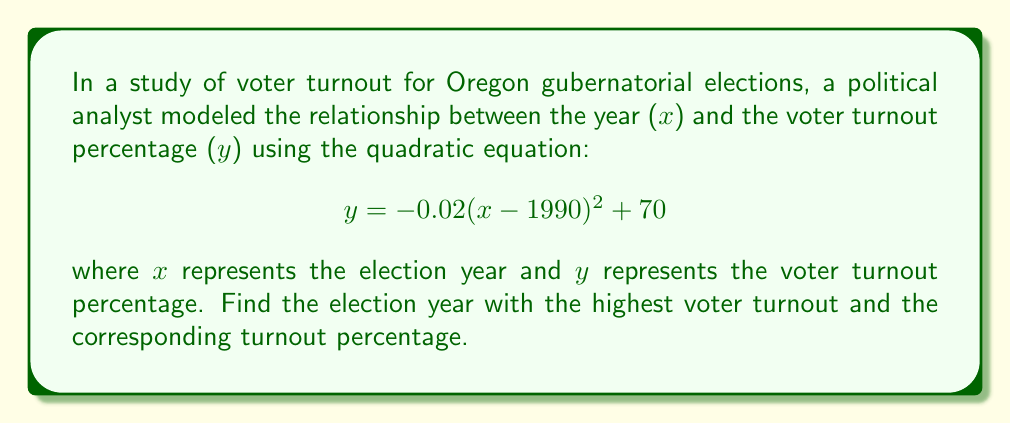Solve this math problem. To solve this problem, we need to find the vertex of the parabola, which represents the maximum point of the quadratic function. The general form of a quadratic equation is:

$$ y = a(x - h)^2 + k $$

where (h, k) is the vertex of the parabola.

In our equation:
$$ y = -0.02(x - 1990)^2 + 70 $$

We can identify that:
a = -0.02
h = 1990
k = 70

The vertex of this parabola is (1990, 70), which means:

1. The election year with the highest voter turnout was 1990.
2. The highest voter turnout percentage was 70%.

This makes sense historically, as 1990 was a significant year in Oregon politics with the election of Barbara Roberts, the state's first female governor.

To verify this is indeed the maximum, we can observe that the coefficient 'a' is negative (-0.02), which means the parabola opens downward, confirming that the vertex is the highest point.
Answer: The election year with the highest voter turnout was 1990, with a turnout percentage of 70%. 